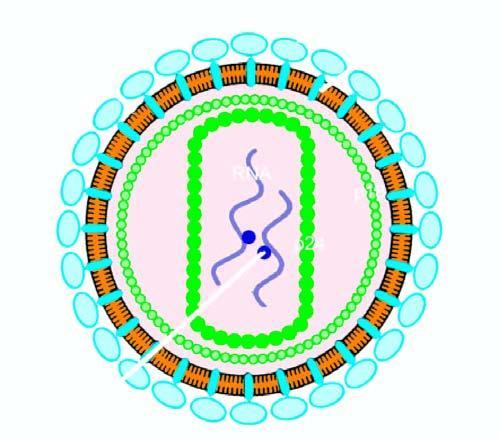does the epidermis have core containing proteins, p24 and p18, two strands of viral rna, and enzyme reverse transcriptase?
Answer the question using a single word or phrase. No 